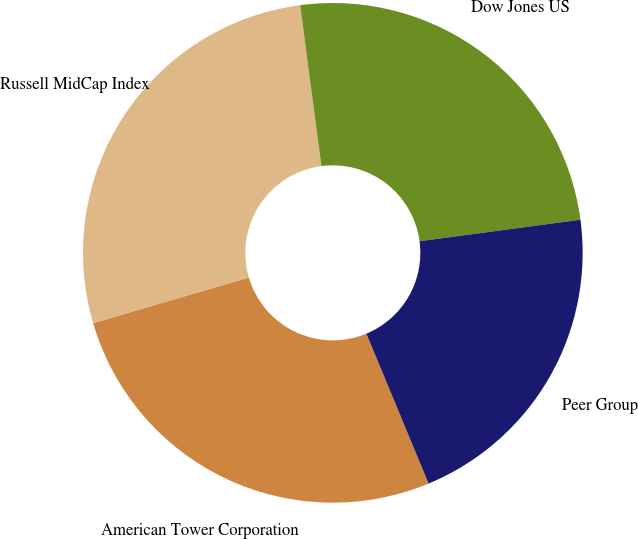Convert chart. <chart><loc_0><loc_0><loc_500><loc_500><pie_chart><fcel>American Tower Corporation<fcel>Russell MidCap Index<fcel>Dow Jones US<fcel>Peer Group<nl><fcel>26.72%<fcel>27.45%<fcel>24.97%<fcel>20.85%<nl></chart> 